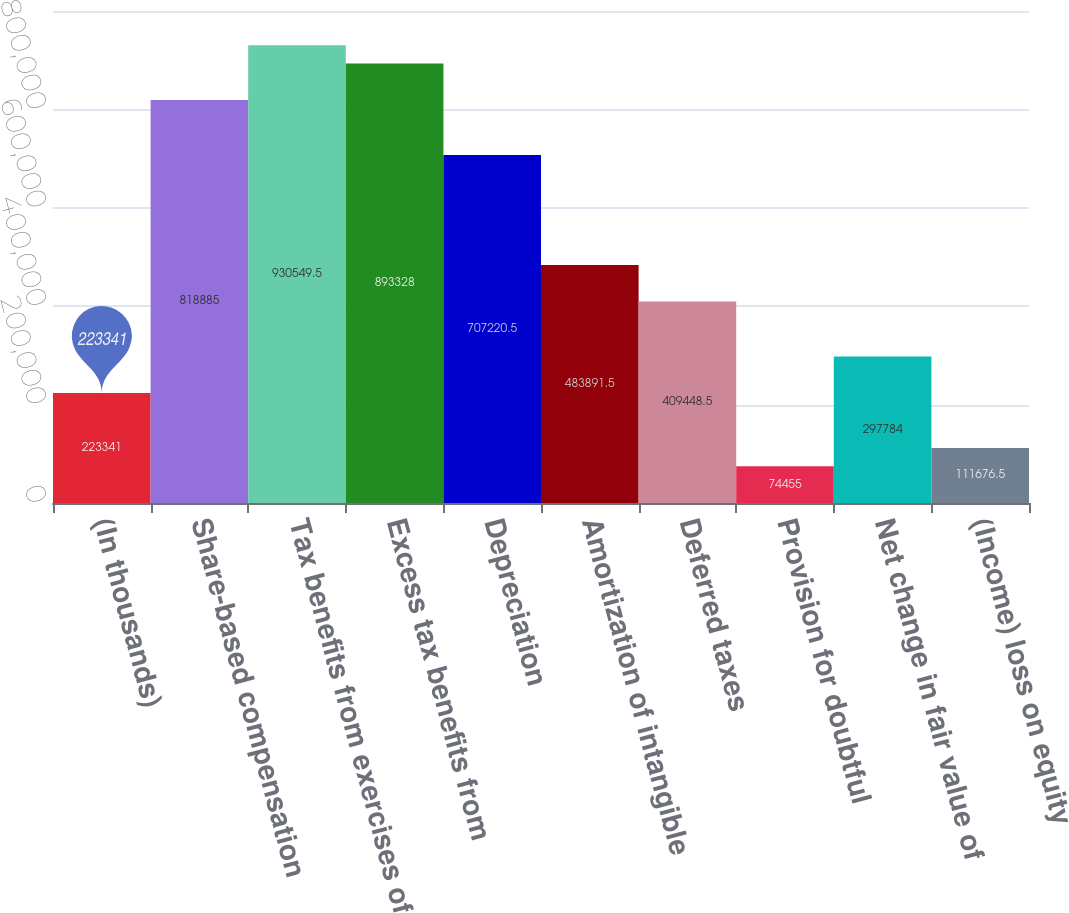Convert chart to OTSL. <chart><loc_0><loc_0><loc_500><loc_500><bar_chart><fcel>(In thousands)<fcel>Share-based compensation<fcel>Tax benefits from exercises of<fcel>Excess tax benefits from<fcel>Depreciation<fcel>Amortization of intangible<fcel>Deferred taxes<fcel>Provision for doubtful<fcel>Net change in fair value of<fcel>(Income) loss on equity<nl><fcel>223341<fcel>818885<fcel>930550<fcel>893328<fcel>707220<fcel>483892<fcel>409448<fcel>74455<fcel>297784<fcel>111676<nl></chart> 